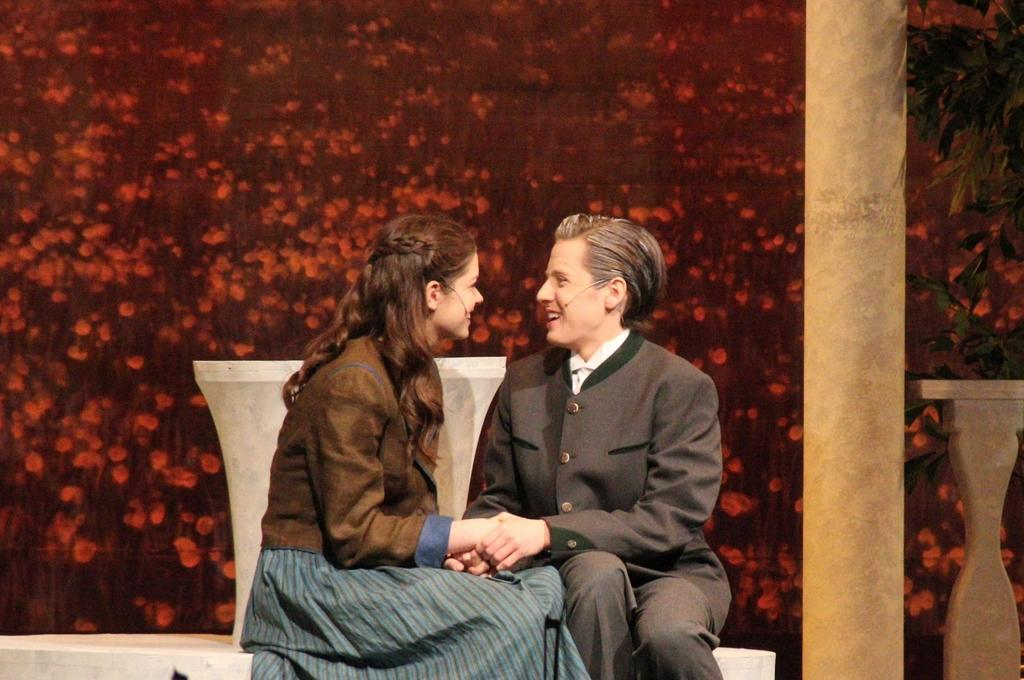Who can be seen in the foreground of the image? There is a couple in the foreground of the image. What are the couple sitting on? The couple is sitting on a white surface. What can be seen in the background of the image? There is a pillar, an object, and a tree in the background of the image. Are there any natural elements depicted in the image? Yes, flowers are depicted in the image. What type of zinc is being used by the army in the image? There is no mention of zinc or the army in the image; it features a couple sitting on a white surface with a background containing a pillar, an object, a tree, and flowers. 